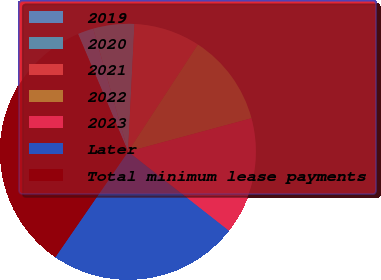Convert chart to OTSL. <chart><loc_0><loc_0><loc_500><loc_500><pie_chart><fcel>2019<fcel>2020<fcel>2021<fcel>2022<fcel>2023<fcel>Later<fcel>Total minimum lease payments<nl><fcel>2.0%<fcel>5.2%<fcel>8.4%<fcel>11.6%<fcel>14.8%<fcel>24.0%<fcel>34.0%<nl></chart> 